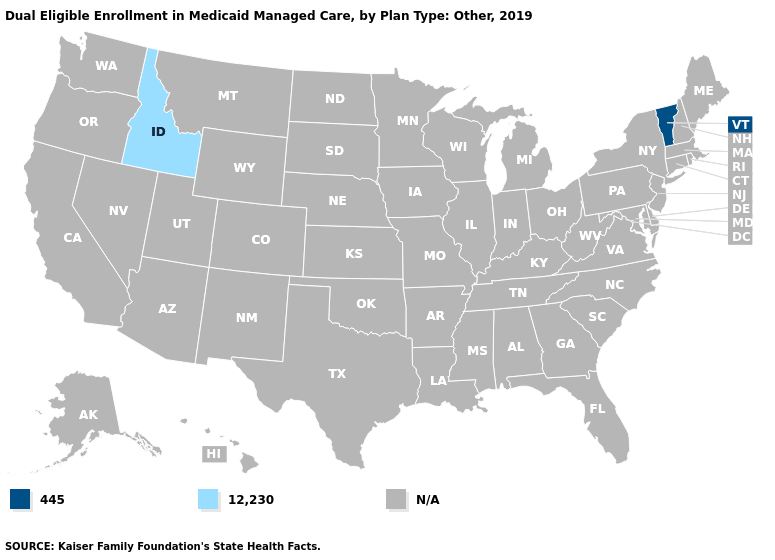Which states have the lowest value in the Northeast?
Be succinct. Vermont. What is the value of Hawaii?
Concise answer only. N/A. What is the value of Kansas?
Answer briefly. N/A. What is the value of Washington?
Concise answer only. N/A. What is the value of Arkansas?
Be succinct. N/A. What is the value of New Mexico?
Quick response, please. N/A. Name the states that have a value in the range N/A?
Write a very short answer. Alabama, Alaska, Arizona, Arkansas, California, Colorado, Connecticut, Delaware, Florida, Georgia, Hawaii, Illinois, Indiana, Iowa, Kansas, Kentucky, Louisiana, Maine, Maryland, Massachusetts, Michigan, Minnesota, Mississippi, Missouri, Montana, Nebraska, Nevada, New Hampshire, New Jersey, New Mexico, New York, North Carolina, North Dakota, Ohio, Oklahoma, Oregon, Pennsylvania, Rhode Island, South Carolina, South Dakota, Tennessee, Texas, Utah, Virginia, Washington, West Virginia, Wisconsin, Wyoming. Which states have the lowest value in the USA?
Keep it brief. Vermont. Name the states that have a value in the range N/A?
Give a very brief answer. Alabama, Alaska, Arizona, Arkansas, California, Colorado, Connecticut, Delaware, Florida, Georgia, Hawaii, Illinois, Indiana, Iowa, Kansas, Kentucky, Louisiana, Maine, Maryland, Massachusetts, Michigan, Minnesota, Mississippi, Missouri, Montana, Nebraska, Nevada, New Hampshire, New Jersey, New Mexico, New York, North Carolina, North Dakota, Ohio, Oklahoma, Oregon, Pennsylvania, Rhode Island, South Carolina, South Dakota, Tennessee, Texas, Utah, Virginia, Washington, West Virginia, Wisconsin, Wyoming. Which states have the highest value in the USA?
Give a very brief answer. Idaho. What is the value of Rhode Island?
Give a very brief answer. N/A. 